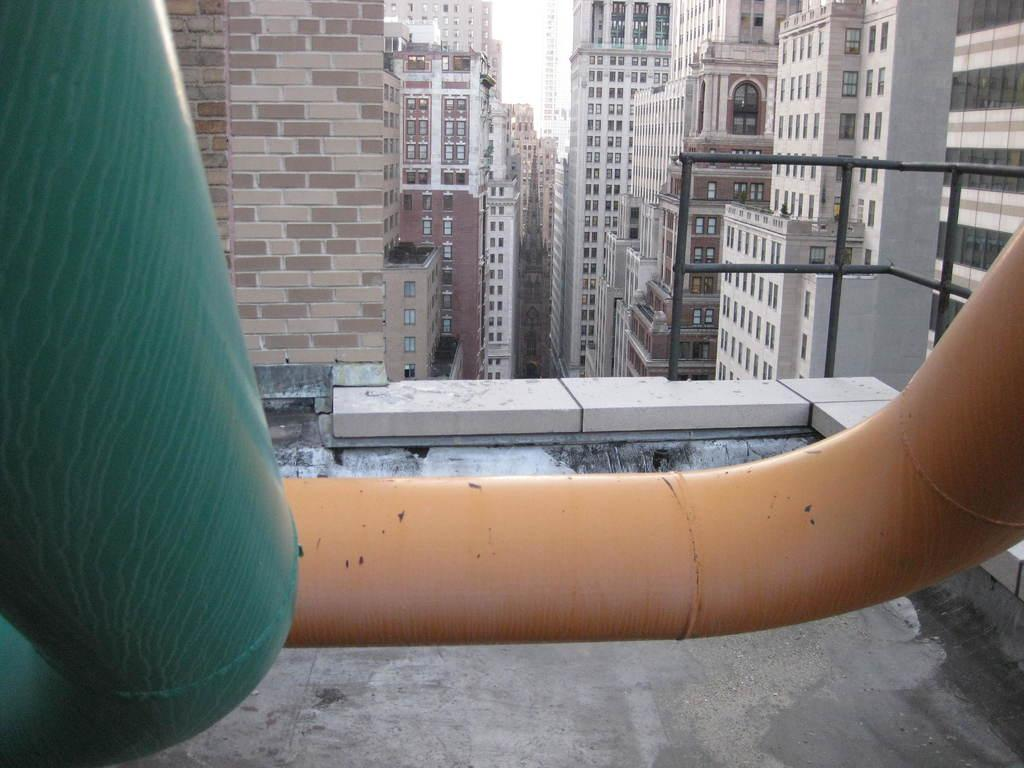What type of structures are present in the image? There are tower buildings in the image. What features can be observed on the tower buildings? The tower buildings have windows and multiple floors. Can you describe the view from the building terrace? There is a part of the sky visible from the building terrace. What type of quill can be seen in the image? There is no quill present in the image. What shape is the tower building in the image? The provided facts do not specify the shape of the tower buildings, so we cannot determine their shape from the image. 